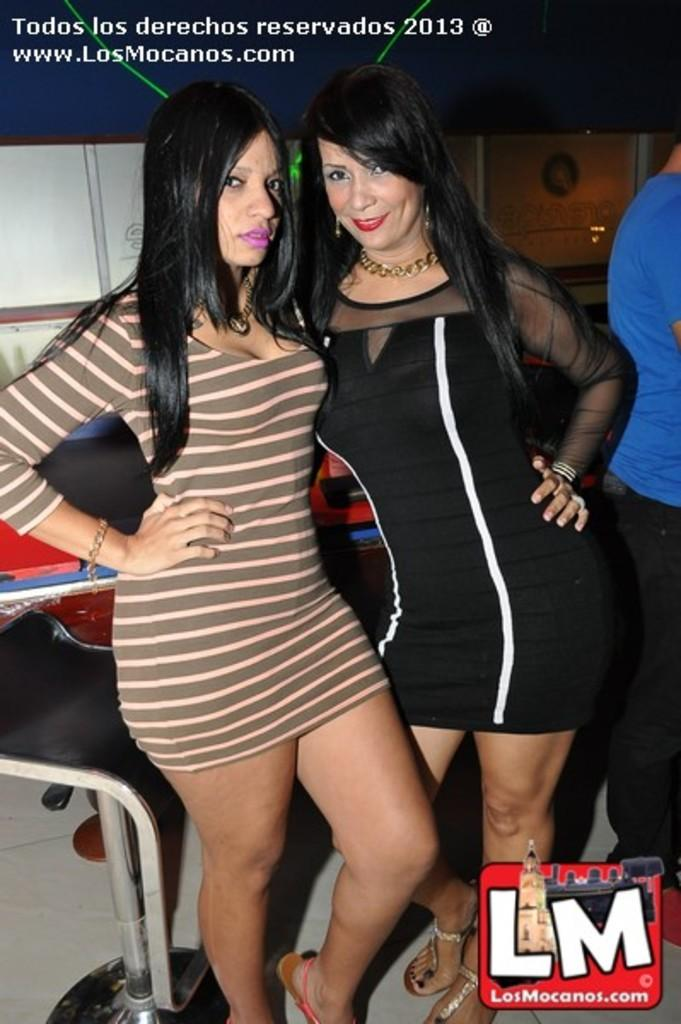How many women are in the image? There are two women in the image. What is at the bottom of the image? There is a floor at the bottom of the image. What can be seen on the left side of the image? There is a chair on the left side of the image. Can you describe the person on the right side of the image? The person on the right side is wearing a blue T-shirt. What type of border is visible around the image? There is no border visible around the image; it is a photograph or digital image without a frame. How many legs does the chair on the left side of the image have? The image does not show the legs of the chair; it only shows the chair's backrest and seat. 